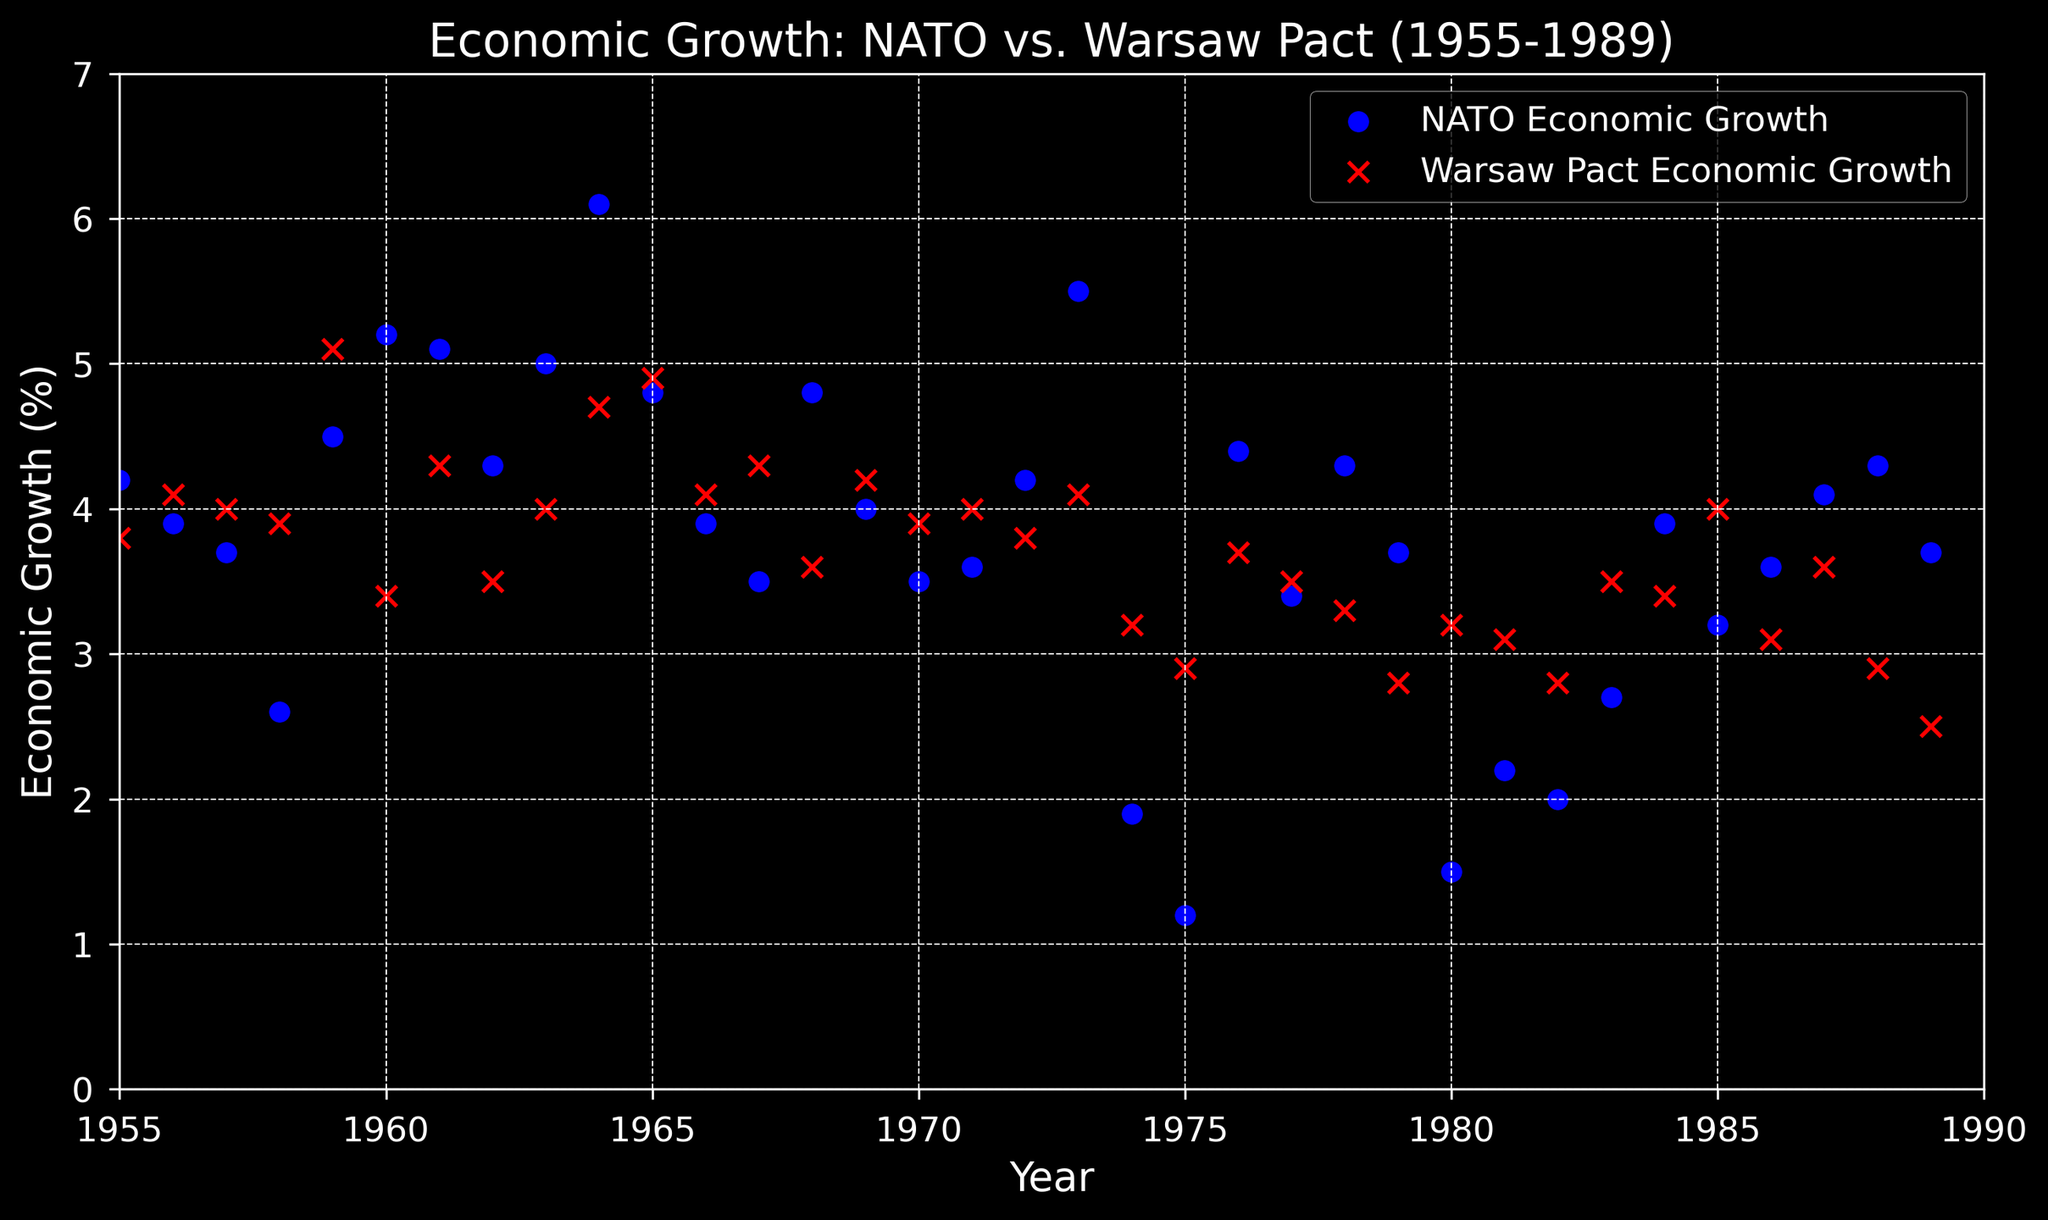What was the average economic growth of NATO countries in the 1960s? To find the average economic growth of NATO countries in the 1960s, locate the data points from 1960 to 1969 and sum them, then divide by the number of data points. The values are [5.2, 5.1, 4.3, 5.0, 6.1, 4.8, 3.9, 3.5, 4.8, 4.0]. Sum these values, which equals 46.7, then divide by 10.
Answer: 4.67% In which year did Warsaw Pact countries have the highest economic growth? Look at the scatter plot and identify the red "x" marker with the highest value along the vertical axis. The highest value is 5.1 in the year 1959.
Answer: 1959 How did the economic growth of NATO countries compare to Warsaw Pact countries in 1974? Find the data points for 1974 for both NATO and Warsaw Pact countries. For NATO, it is 1.9%, and for Warsaw Pact, it is 3.2%. Compare these values.
Answer: Warsaw Pact growth was higher Which decade showed a more consistent economic growth pattern for NATO countries? Visually inspect the scatter plots for NATO from each decade (1955-1965, 1966-1976, 1977-1989). The 1966-1976 decade has a narrower spread of values compared to 1955-1965 and 1977-1989, indicating more consistency.
Answer: 1966-1976 What was the difference in economic growth between NATO and Warsaw Pact countries in 1980? Find the data points for 1980 for both NATO and Warsaw Pact countries. NATO's growth is 1.5%, and Warsaw Pact's is 3.2%. The difference is 3.2% - 1.5% = 1.7%.
Answer: 1.7% Which organization, NATO or Warsaw Pact, had more frequent years of economic growth above 4% from 1955 to 1989? Count the years where economic growth exceeded 4% for both NATO and Warsaw Pact countries from the scatter plot. NATO has 15 instances, and Warsaw Pact has 6.
Answer: NATO What was the median economic growth for Warsaw Pact countries in the 1980s? List the values from 1980 to 1989: 3.2, 3.1, 2.8, 3.5, 3.4, 4.0, 3.1, 3.6, 2.9, 2.5. First, sort these values: [2.5, 2.8, 2.9, 3.1, 3.1, 3.4, 3.5, 3.6, 3.6, 4.0]. With 10 values, take the average of the 5th and 6th values: (3.4 + 3.1) / 2 = 3.25.
Answer: 3.25% In which year was the economic growth of NATO the lowest, and what was the rate? Identify the lowest blue "o" marker. The lowest point is 1.2% in the year 1975.
Answer: 1975, 1.2% 